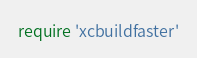Convert code to text. <code><loc_0><loc_0><loc_500><loc_500><_Ruby_>require 'xcbuildfaster'</code> 